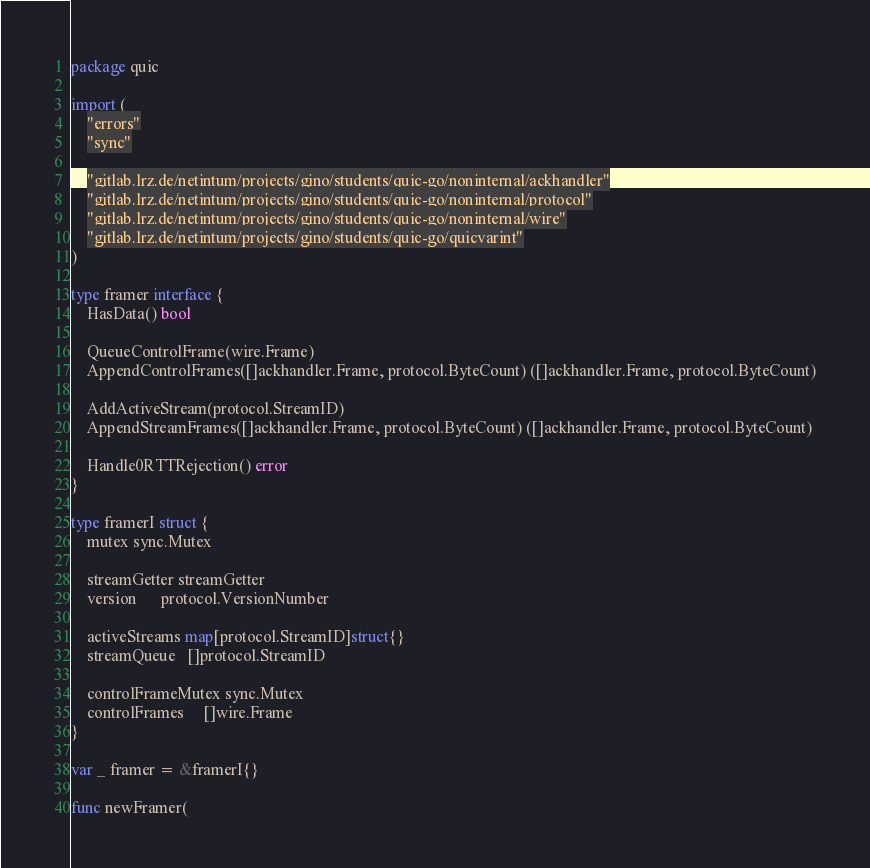<code> <loc_0><loc_0><loc_500><loc_500><_Go_>package quic

import (
	"errors"
	"sync"

	"gitlab.lrz.de/netintum/projects/gino/students/quic-go/noninternal/ackhandler"
	"gitlab.lrz.de/netintum/projects/gino/students/quic-go/noninternal/protocol"
	"gitlab.lrz.de/netintum/projects/gino/students/quic-go/noninternal/wire"
	"gitlab.lrz.de/netintum/projects/gino/students/quic-go/quicvarint"
)

type framer interface {
	HasData() bool

	QueueControlFrame(wire.Frame)
	AppendControlFrames([]ackhandler.Frame, protocol.ByteCount) ([]ackhandler.Frame, protocol.ByteCount)

	AddActiveStream(protocol.StreamID)
	AppendStreamFrames([]ackhandler.Frame, protocol.ByteCount) ([]ackhandler.Frame, protocol.ByteCount)

	Handle0RTTRejection() error
}

type framerI struct {
	mutex sync.Mutex

	streamGetter streamGetter
	version      protocol.VersionNumber

	activeStreams map[protocol.StreamID]struct{}
	streamQueue   []protocol.StreamID

	controlFrameMutex sync.Mutex
	controlFrames     []wire.Frame
}

var _ framer = &framerI{}

func newFramer(</code> 